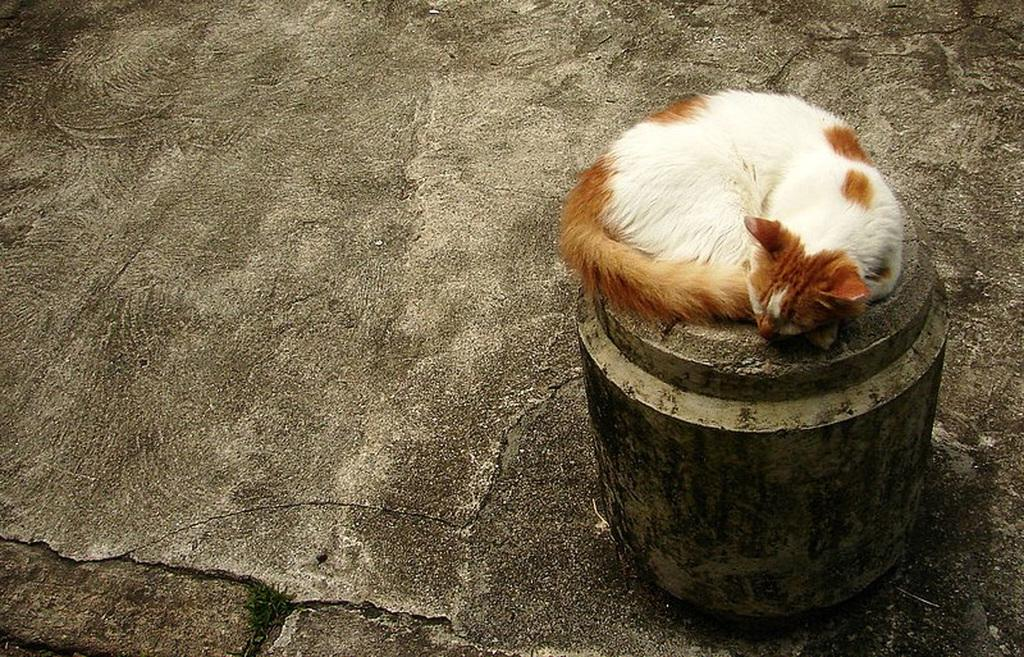What animal is present in the image? There is a cat in the image. What is the cat lying on? The cat is lying on a stone object. Can you tell if the image was taken during the day or night? The image might have been taken during the day. What type of blood is visible on the cat's paw in the image? There is no blood visible on the cat's paw in the image. What kind of machine is being operated by the cat in the image? There is no machine present in the image, and the cat is not operating anything. 